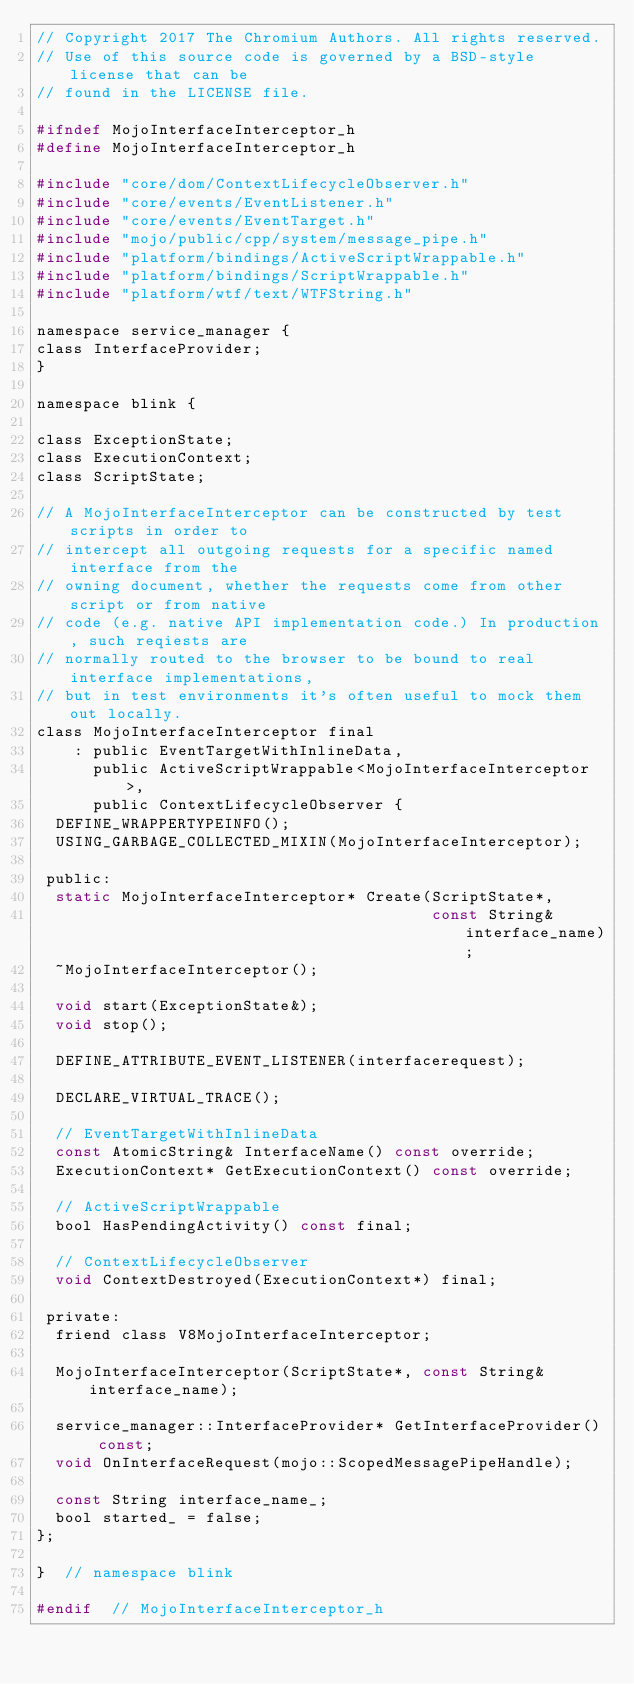Convert code to text. <code><loc_0><loc_0><loc_500><loc_500><_C_>// Copyright 2017 The Chromium Authors. All rights reserved.
// Use of this source code is governed by a BSD-style license that can be
// found in the LICENSE file.

#ifndef MojoInterfaceInterceptor_h
#define MojoInterfaceInterceptor_h

#include "core/dom/ContextLifecycleObserver.h"
#include "core/events/EventListener.h"
#include "core/events/EventTarget.h"
#include "mojo/public/cpp/system/message_pipe.h"
#include "platform/bindings/ActiveScriptWrappable.h"
#include "platform/bindings/ScriptWrappable.h"
#include "platform/wtf/text/WTFString.h"

namespace service_manager {
class InterfaceProvider;
}

namespace blink {

class ExceptionState;
class ExecutionContext;
class ScriptState;

// A MojoInterfaceInterceptor can be constructed by test scripts in order to
// intercept all outgoing requests for a specific named interface from the
// owning document, whether the requests come from other script or from native
// code (e.g. native API implementation code.) In production, such reqiests are
// normally routed to the browser to be bound to real interface implementations,
// but in test environments it's often useful to mock them out locally.
class MojoInterfaceInterceptor final
    : public EventTargetWithInlineData,
      public ActiveScriptWrappable<MojoInterfaceInterceptor>,
      public ContextLifecycleObserver {
  DEFINE_WRAPPERTYPEINFO();
  USING_GARBAGE_COLLECTED_MIXIN(MojoInterfaceInterceptor);

 public:
  static MojoInterfaceInterceptor* Create(ScriptState*,
                                          const String& interface_name);
  ~MojoInterfaceInterceptor();

  void start(ExceptionState&);
  void stop();

  DEFINE_ATTRIBUTE_EVENT_LISTENER(interfacerequest);

  DECLARE_VIRTUAL_TRACE();

  // EventTargetWithInlineData
  const AtomicString& InterfaceName() const override;
  ExecutionContext* GetExecutionContext() const override;

  // ActiveScriptWrappable
  bool HasPendingActivity() const final;

  // ContextLifecycleObserver
  void ContextDestroyed(ExecutionContext*) final;

 private:
  friend class V8MojoInterfaceInterceptor;

  MojoInterfaceInterceptor(ScriptState*, const String& interface_name);

  service_manager::InterfaceProvider* GetInterfaceProvider() const;
  void OnInterfaceRequest(mojo::ScopedMessagePipeHandle);

  const String interface_name_;
  bool started_ = false;
};

}  // namespace blink

#endif  // MojoInterfaceInterceptor_h
</code> 